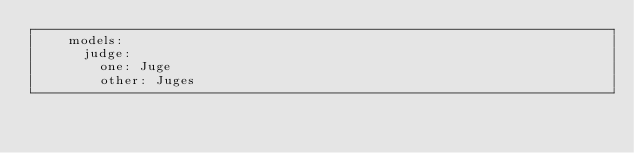Convert code to text. <code><loc_0><loc_0><loc_500><loc_500><_YAML_>    models:
      judge:
        one: Juge
        other: Juges
</code> 